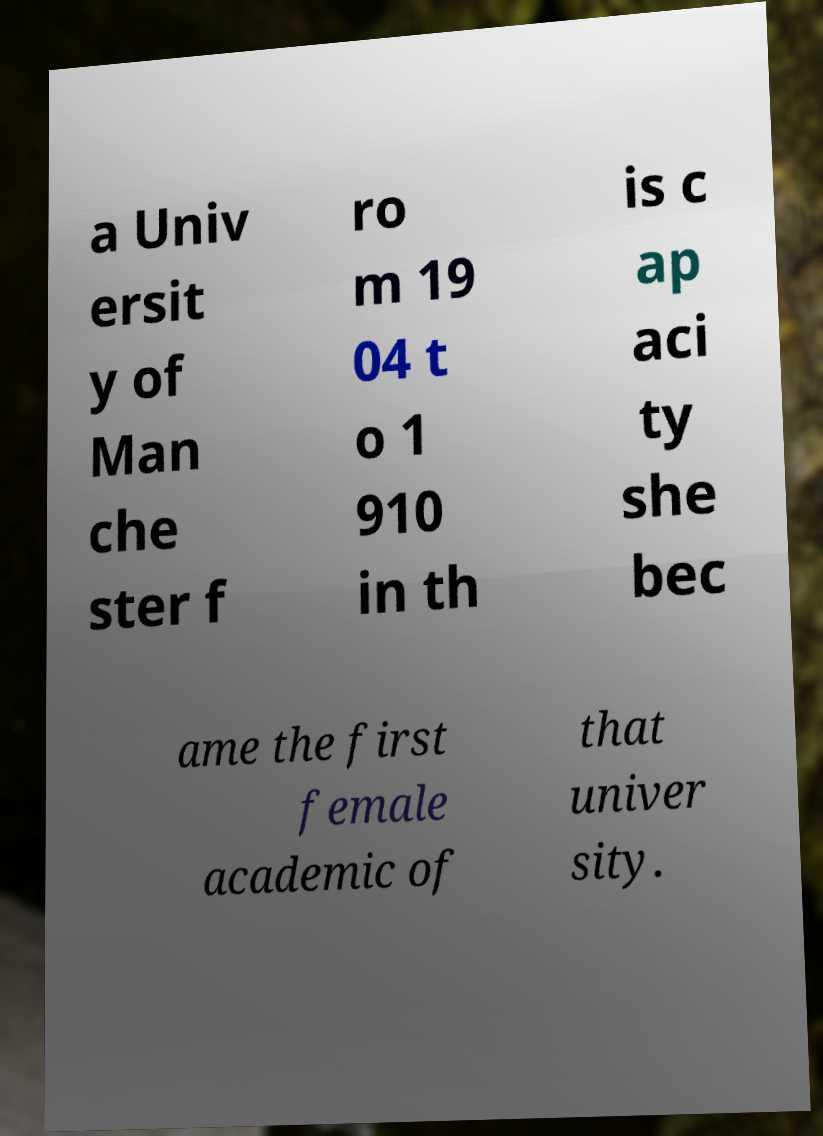Can you read and provide the text displayed in the image?This photo seems to have some interesting text. Can you extract and type it out for me? a Univ ersit y of Man che ster f ro m 19 04 t o 1 910 in th is c ap aci ty she bec ame the first female academic of that univer sity. 